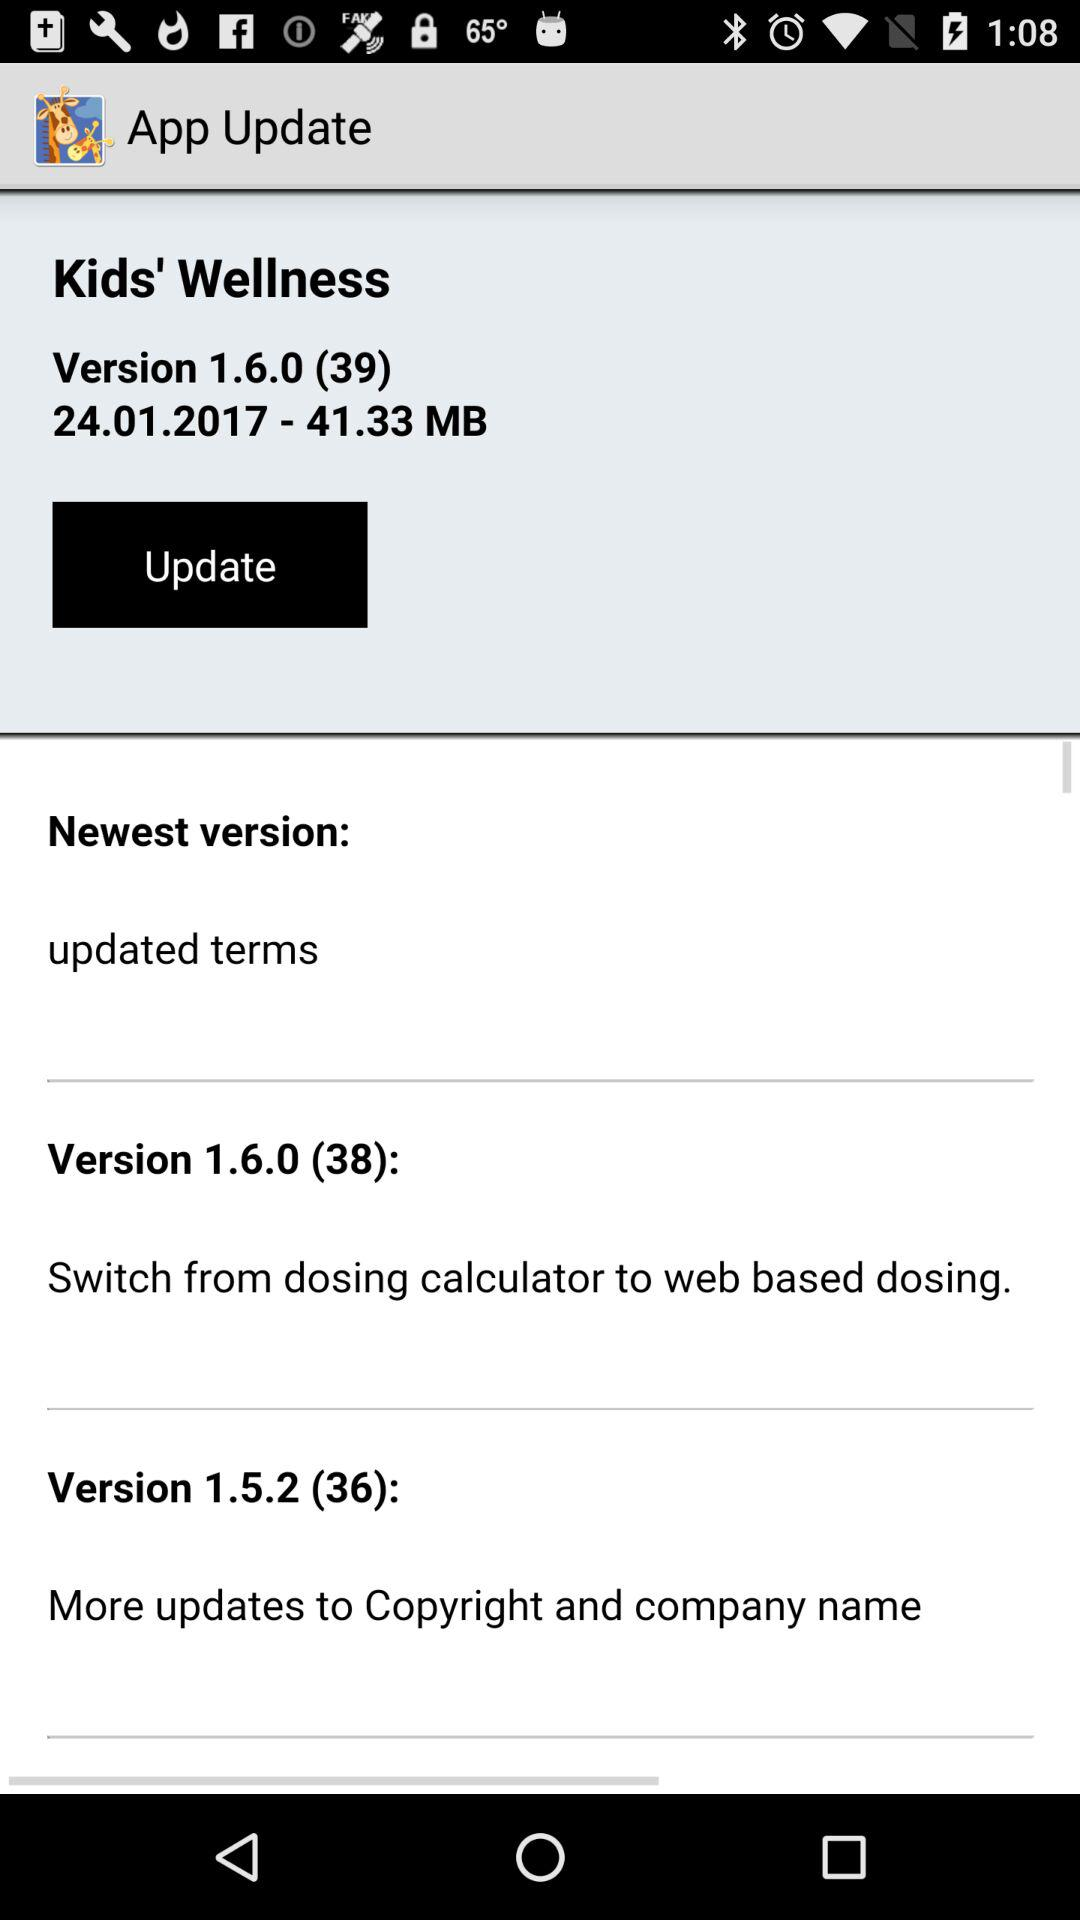What version can the app be updated to? The app can be updated to version 1.6.0 (39). 